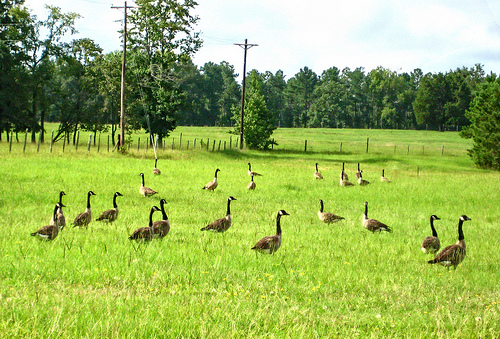<image>
Can you confirm if the bird is on the grass? Yes. Looking at the image, I can see the bird is positioned on top of the grass, with the grass providing support. 